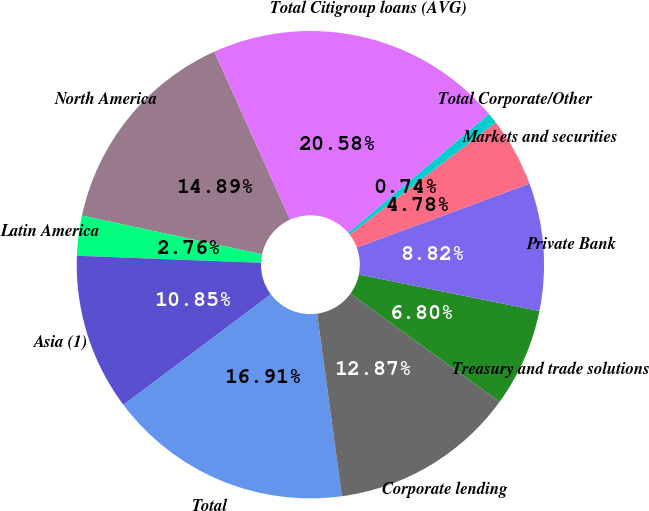Convert chart. <chart><loc_0><loc_0><loc_500><loc_500><pie_chart><fcel>North America<fcel>Latin America<fcel>Asia (1)<fcel>Total<fcel>Corporate lending<fcel>Treasury and trade solutions<fcel>Private Bank<fcel>Markets and securities<fcel>Total Corporate/Other<fcel>Total Citigroup loans (AVG)<nl><fcel>14.89%<fcel>2.76%<fcel>10.85%<fcel>16.91%<fcel>12.87%<fcel>6.8%<fcel>8.82%<fcel>4.78%<fcel>0.74%<fcel>20.58%<nl></chart> 